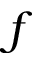Convert formula to latex. <formula><loc_0><loc_0><loc_500><loc_500>f</formula> 